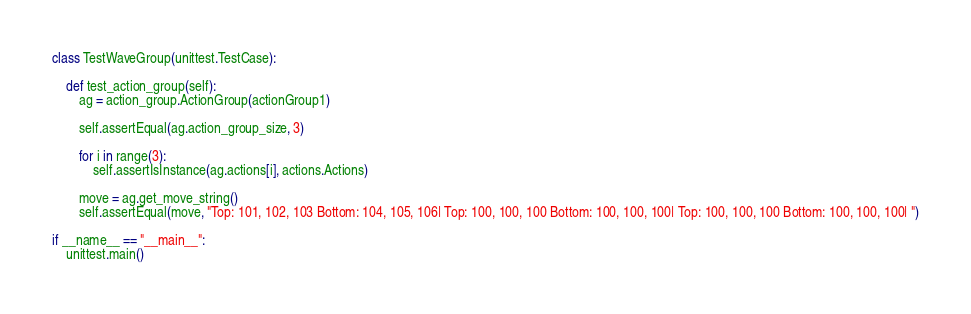<code> <loc_0><loc_0><loc_500><loc_500><_Python_>

class TestWaveGroup(unittest.TestCase):

    def test_action_group(self):
        ag = action_group.ActionGroup(actionGroup1)
        
        self.assertEqual(ag.action_group_size, 3)
        
        for i in range(3):
            self.assertIsInstance(ag.actions[i], actions.Actions)

        move = ag.get_move_string()
        self.assertEqual(move, "Top: 101, 102, 103 Bottom: 104, 105, 106| Top: 100, 100, 100 Bottom: 100, 100, 100| Top: 100, 100, 100 Bottom: 100, 100, 100| ")

if __name__ == "__main__":
    unittest.main()</code> 